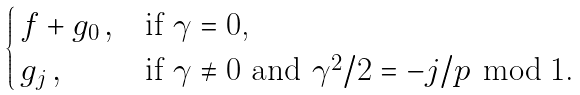<formula> <loc_0><loc_0><loc_500><loc_500>\begin{cases} \, f + g _ { 0 } \, , & \text {if $\gamma = 0$,} \\ \, g _ { j } \, , & \text {if $\gamma \neq 0$ and                 $\gamma^{2}/2 = -j/p \,\bmod 1$.} \end{cases}</formula> 